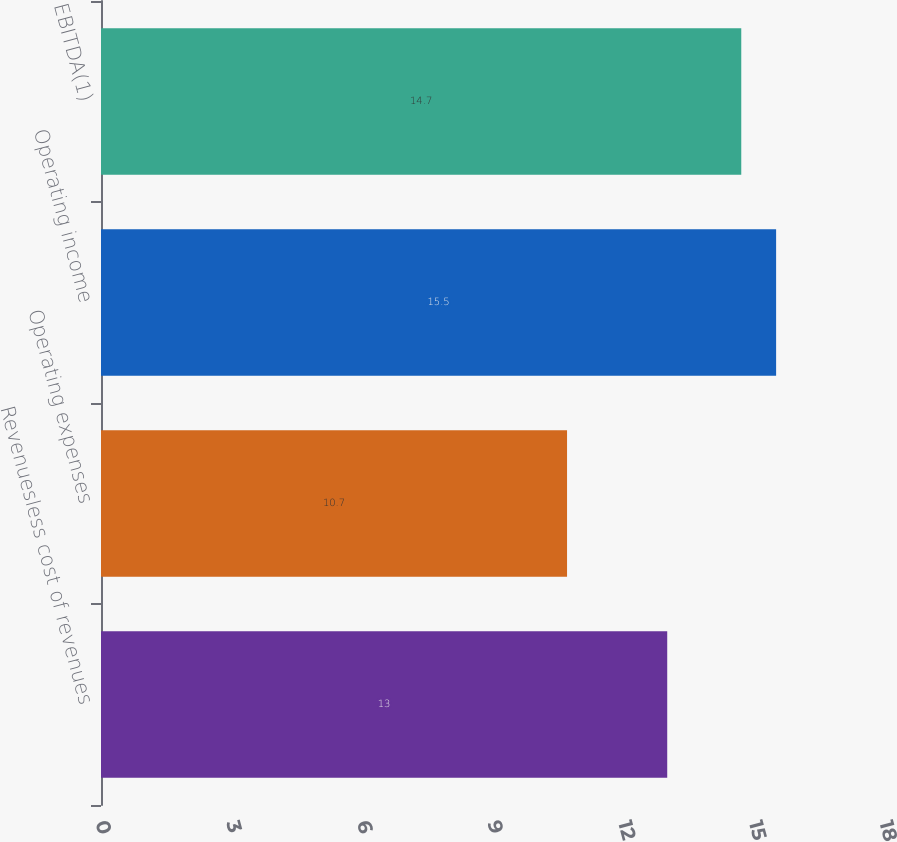Convert chart. <chart><loc_0><loc_0><loc_500><loc_500><bar_chart><fcel>Revenuesless cost of revenues<fcel>Operating expenses<fcel>Operating income<fcel>EBITDA(1)<nl><fcel>13<fcel>10.7<fcel>15.5<fcel>14.7<nl></chart> 